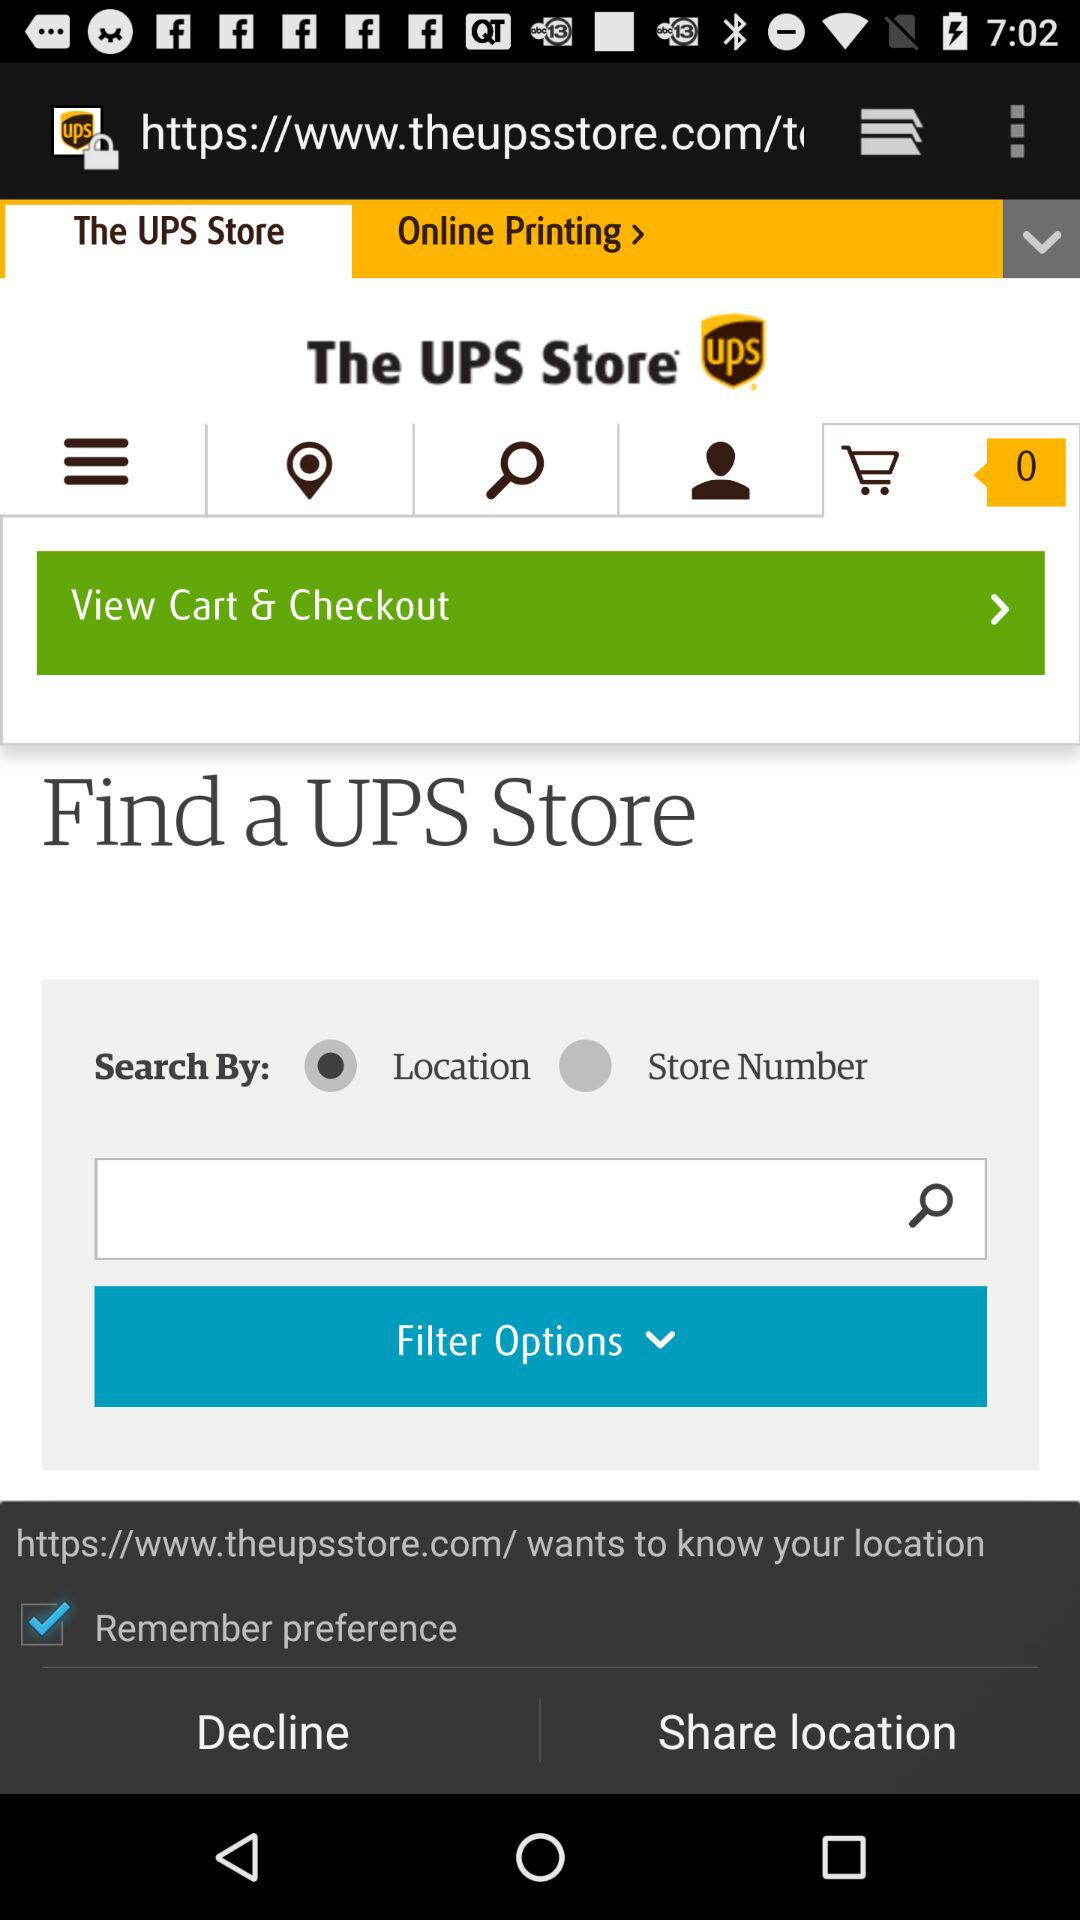What is the status of the "Remember preference"? The status of the "Remember preference" is "on". 